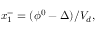<formula> <loc_0><loc_0><loc_500><loc_500>x _ { 1 } ^ { - } = ( \phi ^ { 0 } - \Delta ) / V _ { d } ,</formula> 